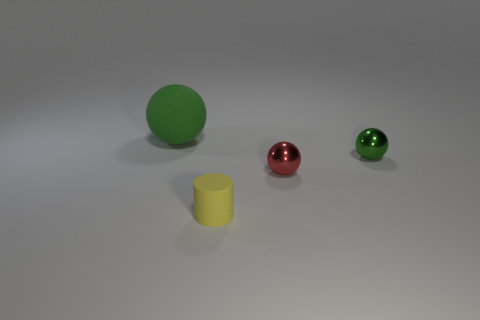There is a rubber thing that is to the right of the big sphere; is its shape the same as the green matte thing?
Offer a terse response. No. There is a small object right of the red shiny thing; what is its material?
Give a very brief answer. Metal. Is there a tiny cyan sphere made of the same material as the yellow thing?
Keep it short and to the point. No. What is the size of the rubber ball?
Offer a very short reply. Large. How many green things are tiny metal balls or matte balls?
Offer a terse response. 2. What number of tiny yellow rubber things are the same shape as the red shiny thing?
Make the answer very short. 0. What number of cylinders are the same size as the red thing?
Your answer should be very brief. 1. There is a red object that is the same shape as the tiny green metallic object; what is it made of?
Your response must be concise. Metal. What color is the matte object to the right of the large ball?
Keep it short and to the point. Yellow. Is the number of large matte balls that are on the left side of the small red thing greater than the number of large blue matte spheres?
Provide a succinct answer. Yes. 